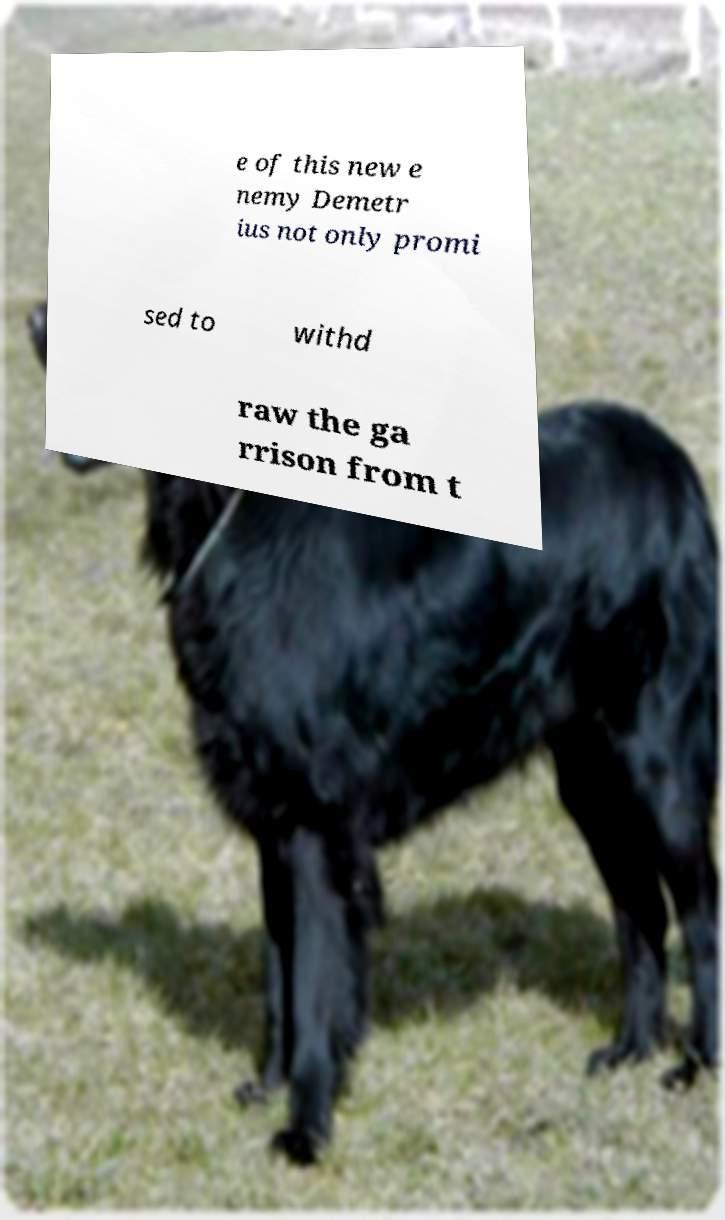Please read and relay the text visible in this image. What does it say? e of this new e nemy Demetr ius not only promi sed to withd raw the ga rrison from t 